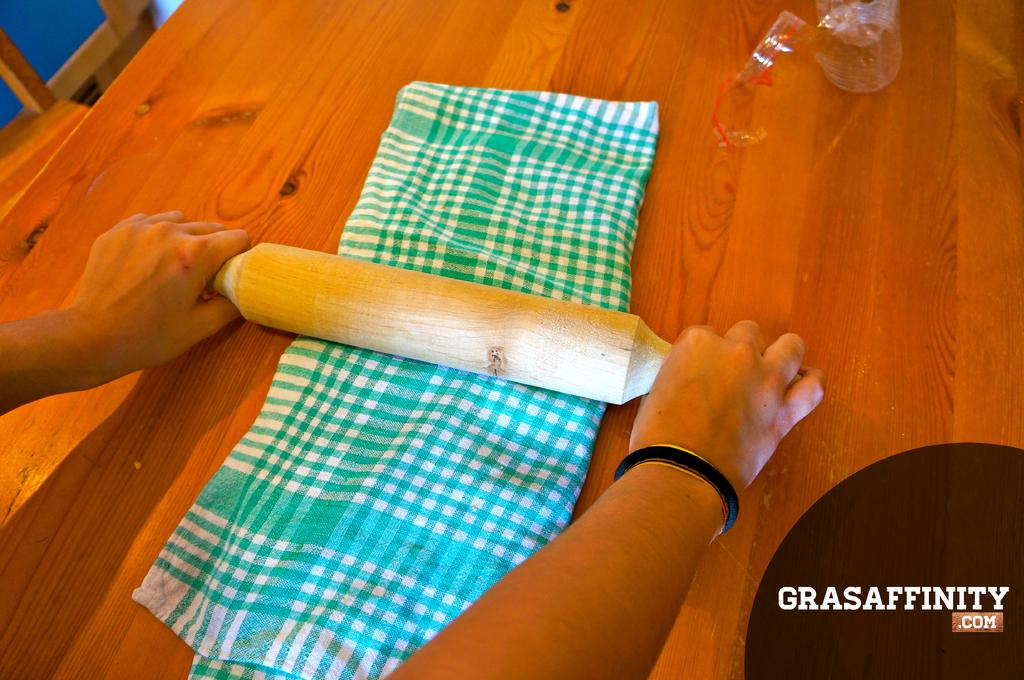What is the person's hand holding in the image? The person's hand is holding a roti roller in the image. Where is the roti roller located in the image? The roti roller is in the center of the image. What else can be seen on the table in the image? There is a cloth on a table in the image. What type of paste is being applied to the cattle in the image? There are no cattle or paste present in the image. 